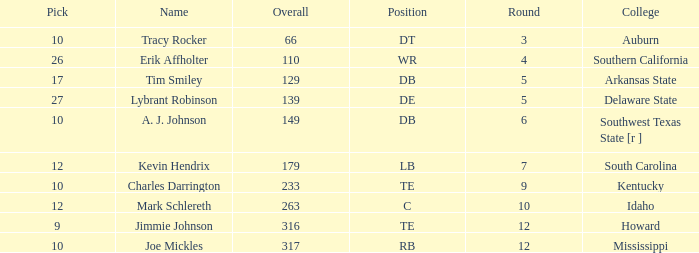What is the sum of Overall, when College is "Arkansas State", and when Pick is less than 17? None. 